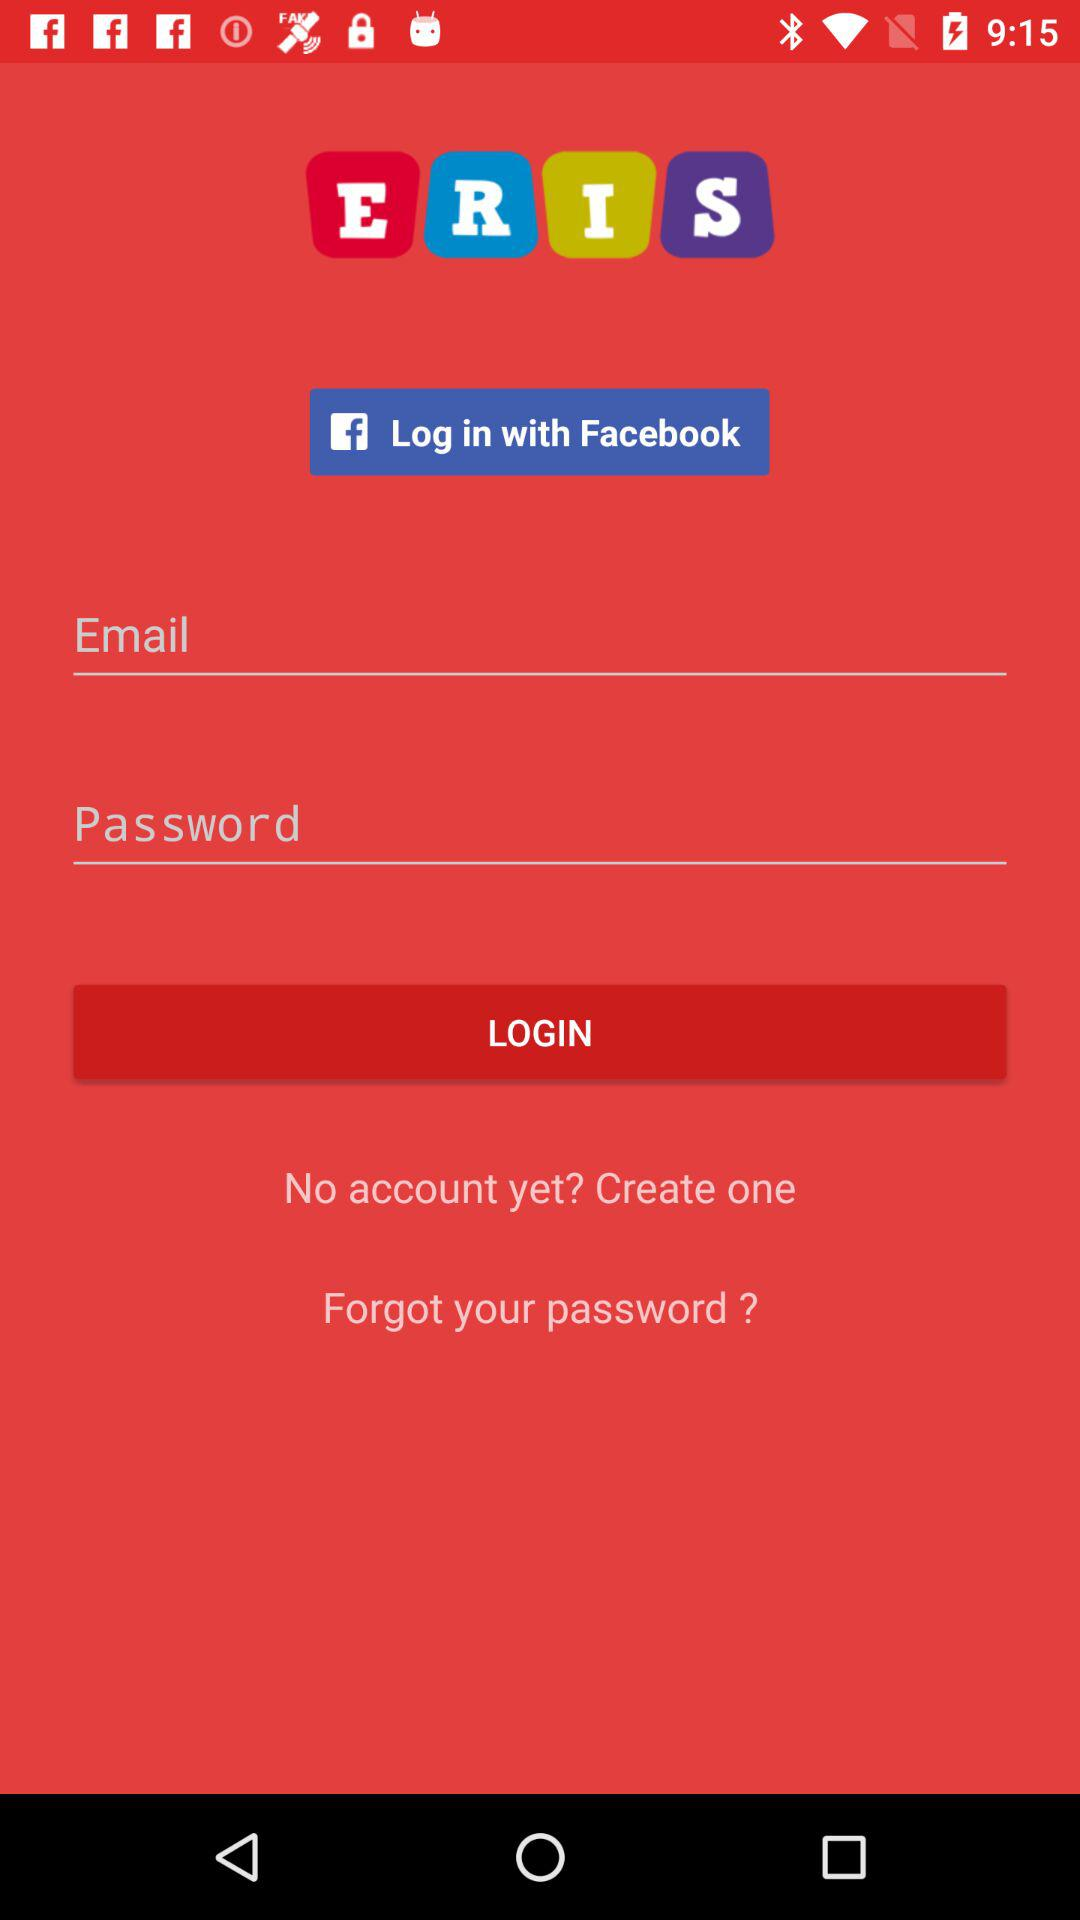What are the options through which we can log in? The options through which you can log in are "Facebook" and "Email". 